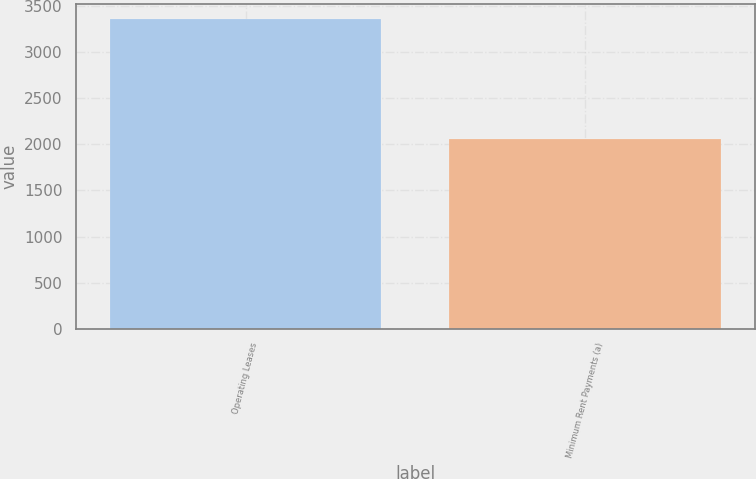Convert chart to OTSL. <chart><loc_0><loc_0><loc_500><loc_500><bar_chart><fcel>Operating Leases<fcel>Minimum Rent Payments (a)<nl><fcel>3356<fcel>2058<nl></chart> 